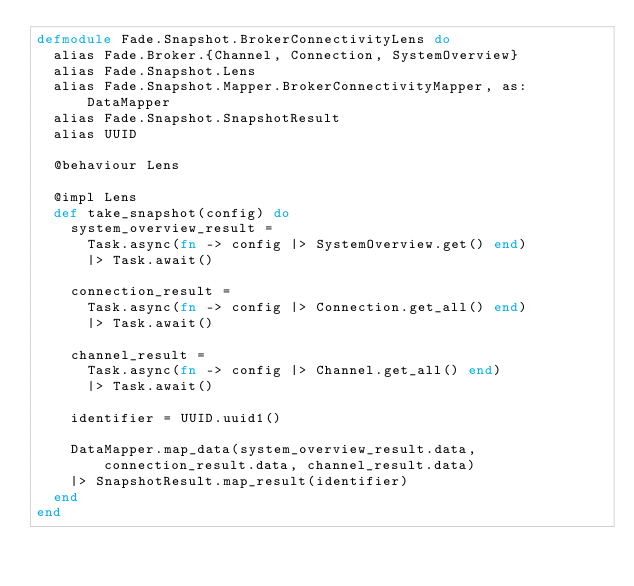<code> <loc_0><loc_0><loc_500><loc_500><_Elixir_>defmodule Fade.Snapshot.BrokerConnectivityLens do
  alias Fade.Broker.{Channel, Connection, SystemOverview}
  alias Fade.Snapshot.Lens
  alias Fade.Snapshot.Mapper.BrokerConnectivityMapper, as: DataMapper
  alias Fade.Snapshot.SnapshotResult
  alias UUID

  @behaviour Lens

  @impl Lens
  def take_snapshot(config) do
    system_overview_result =
      Task.async(fn -> config |> SystemOverview.get() end)
      |> Task.await()

    connection_result =
      Task.async(fn -> config |> Connection.get_all() end)
      |> Task.await()

    channel_result =
      Task.async(fn -> config |> Channel.get_all() end)
      |> Task.await()

    identifier = UUID.uuid1()

    DataMapper.map_data(system_overview_result.data, connection_result.data, channel_result.data)
    |> SnapshotResult.map_result(identifier)
  end
end
</code> 